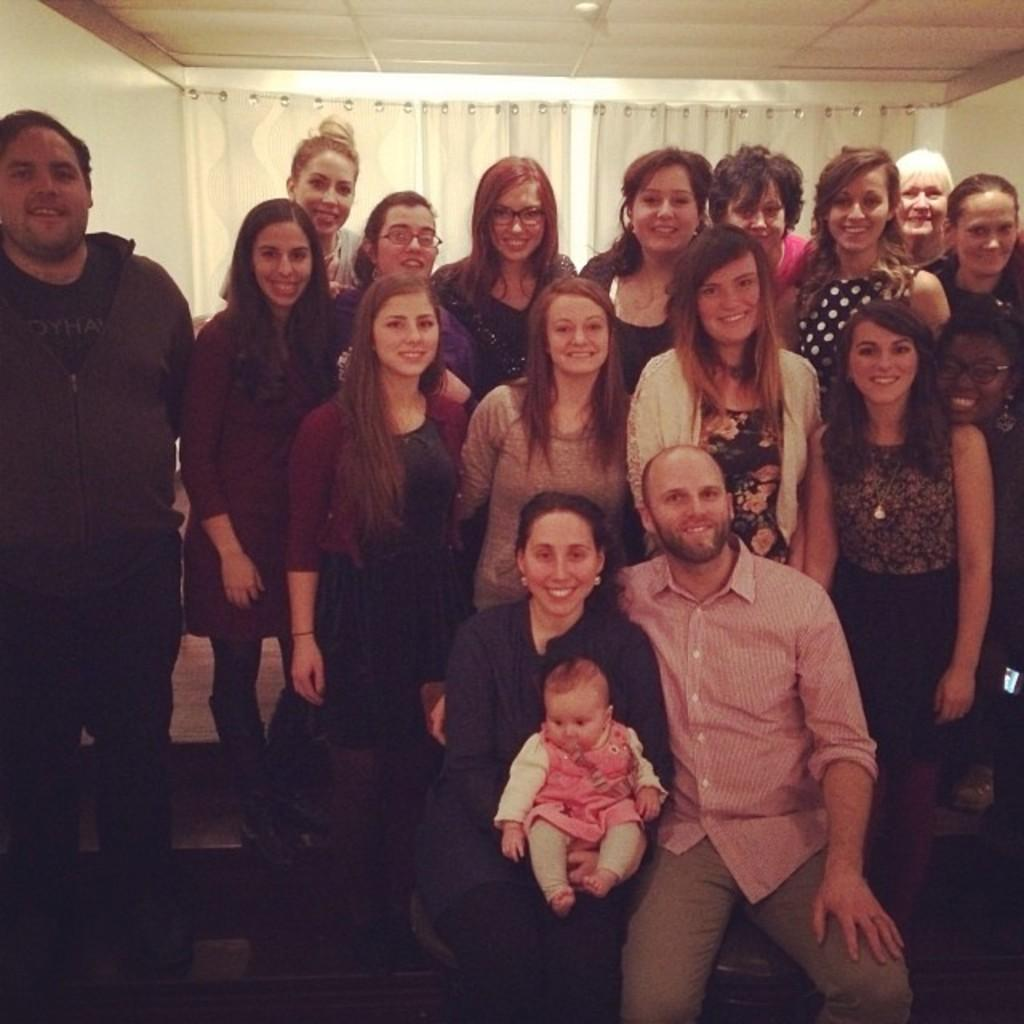How many people are in the image? There is a group of people in the image, but the exact number is not specified. What are the people in the image doing? Some people are seated, while others are standing, and they are all smiling. What can be seen in the background of the image? There are curtains in the background of the image. What type of fowl is being written about in the image? There is no writing or fowl present in the image; it features a group of people with some seated and others standing, all smiling. 